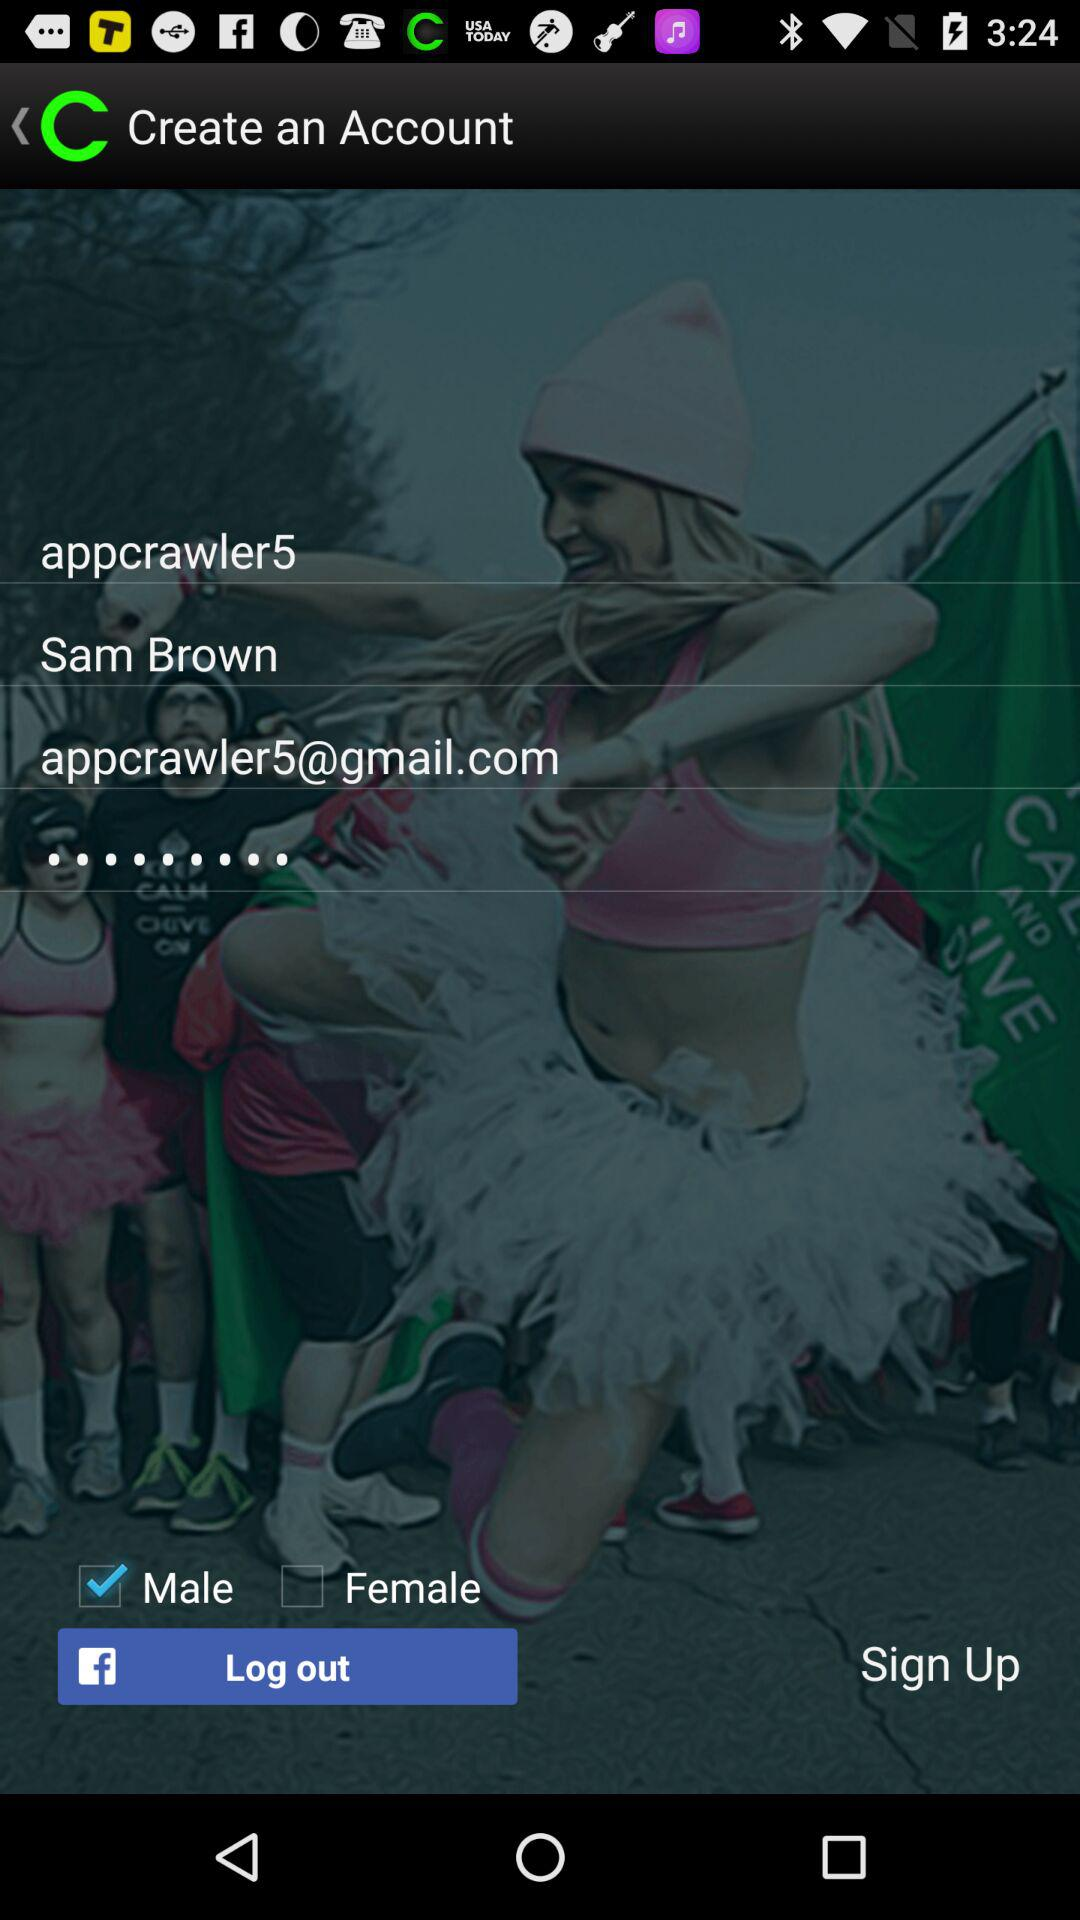What is the email address of the user? The email address is appcrawler5@gmail.com. 